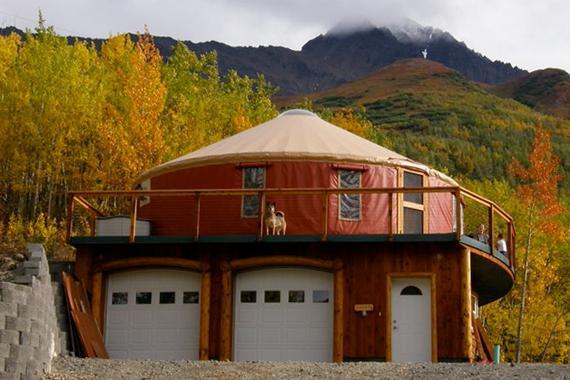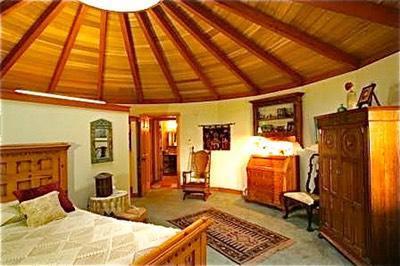The first image is the image on the left, the second image is the image on the right. For the images displayed, is the sentence "An interior and an exterior image of a round house are shown." factually correct? Answer yes or no. Yes. 